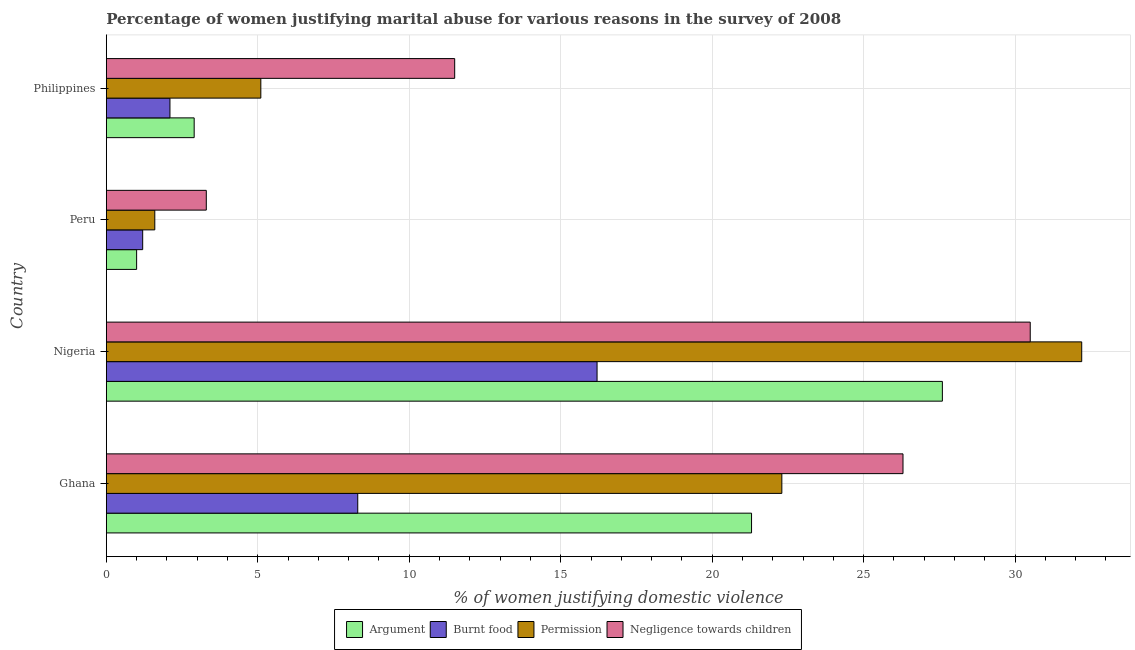How many groups of bars are there?
Give a very brief answer. 4. Are the number of bars on each tick of the Y-axis equal?
Provide a short and direct response. Yes. How many bars are there on the 4th tick from the bottom?
Ensure brevity in your answer.  4. What is the label of the 3rd group of bars from the top?
Give a very brief answer. Nigeria. In how many cases, is the number of bars for a given country not equal to the number of legend labels?
Ensure brevity in your answer.  0. Across all countries, what is the maximum percentage of women justifying abuse for going without permission?
Offer a terse response. 32.2. Across all countries, what is the minimum percentage of women justifying abuse in the case of an argument?
Your answer should be compact. 1. In which country was the percentage of women justifying abuse for going without permission maximum?
Offer a very short reply. Nigeria. In which country was the percentage of women justifying abuse for burning food minimum?
Make the answer very short. Peru. What is the total percentage of women justifying abuse for going without permission in the graph?
Give a very brief answer. 61.2. What is the difference between the percentage of women justifying abuse for showing negligence towards children in Ghana and that in Peru?
Offer a very short reply. 23. What is the difference between the percentage of women justifying abuse in the case of an argument in Nigeria and the percentage of women justifying abuse for burning food in Ghana?
Your response must be concise. 19.3. What is the average percentage of women justifying abuse for burning food per country?
Your response must be concise. 6.95. What is the difference between the percentage of women justifying abuse for going without permission and percentage of women justifying abuse in the case of an argument in Ghana?
Your answer should be very brief. 1. In how many countries, is the percentage of women justifying abuse in the case of an argument greater than 31 %?
Your answer should be very brief. 0. What is the ratio of the percentage of women justifying abuse in the case of an argument in Peru to that in Philippines?
Keep it short and to the point. 0.34. Is the percentage of women justifying abuse in the case of an argument in Nigeria less than that in Philippines?
Your answer should be very brief. No. Is the difference between the percentage of women justifying abuse in the case of an argument in Ghana and Philippines greater than the difference between the percentage of women justifying abuse for burning food in Ghana and Philippines?
Give a very brief answer. Yes. What is the difference between the highest and the second highest percentage of women justifying abuse in the case of an argument?
Ensure brevity in your answer.  6.3. What is the difference between the highest and the lowest percentage of women justifying abuse for showing negligence towards children?
Offer a very short reply. 27.2. Is the sum of the percentage of women justifying abuse for going without permission in Ghana and Nigeria greater than the maximum percentage of women justifying abuse for showing negligence towards children across all countries?
Make the answer very short. Yes. Is it the case that in every country, the sum of the percentage of women justifying abuse for burning food and percentage of women justifying abuse in the case of an argument is greater than the sum of percentage of women justifying abuse for showing negligence towards children and percentage of women justifying abuse for going without permission?
Provide a short and direct response. No. What does the 1st bar from the top in Ghana represents?
Offer a very short reply. Negligence towards children. What does the 1st bar from the bottom in Peru represents?
Offer a very short reply. Argument. Are all the bars in the graph horizontal?
Your answer should be compact. Yes. Does the graph contain any zero values?
Your answer should be compact. No. Does the graph contain grids?
Your answer should be very brief. Yes. How many legend labels are there?
Provide a succinct answer. 4. How are the legend labels stacked?
Keep it short and to the point. Horizontal. What is the title of the graph?
Your answer should be compact. Percentage of women justifying marital abuse for various reasons in the survey of 2008. What is the label or title of the X-axis?
Offer a terse response. % of women justifying domestic violence. What is the % of women justifying domestic violence of Argument in Ghana?
Ensure brevity in your answer.  21.3. What is the % of women justifying domestic violence in Permission in Ghana?
Give a very brief answer. 22.3. What is the % of women justifying domestic violence in Negligence towards children in Ghana?
Your answer should be very brief. 26.3. What is the % of women justifying domestic violence in Argument in Nigeria?
Make the answer very short. 27.6. What is the % of women justifying domestic violence in Permission in Nigeria?
Ensure brevity in your answer.  32.2. What is the % of women justifying domestic violence of Negligence towards children in Nigeria?
Keep it short and to the point. 30.5. What is the % of women justifying domestic violence in Burnt food in Peru?
Provide a short and direct response. 1.2. What is the % of women justifying domestic violence in Permission in Peru?
Provide a short and direct response. 1.6. What is the % of women justifying domestic violence in Burnt food in Philippines?
Your answer should be very brief. 2.1. What is the % of women justifying domestic violence of Permission in Philippines?
Provide a short and direct response. 5.1. Across all countries, what is the maximum % of women justifying domestic violence in Argument?
Provide a succinct answer. 27.6. Across all countries, what is the maximum % of women justifying domestic violence in Burnt food?
Your answer should be very brief. 16.2. Across all countries, what is the maximum % of women justifying domestic violence of Permission?
Make the answer very short. 32.2. Across all countries, what is the maximum % of women justifying domestic violence in Negligence towards children?
Your answer should be compact. 30.5. Across all countries, what is the minimum % of women justifying domestic violence of Argument?
Provide a short and direct response. 1. Across all countries, what is the minimum % of women justifying domestic violence in Burnt food?
Offer a terse response. 1.2. Across all countries, what is the minimum % of women justifying domestic violence in Permission?
Ensure brevity in your answer.  1.6. Across all countries, what is the minimum % of women justifying domestic violence of Negligence towards children?
Provide a succinct answer. 3.3. What is the total % of women justifying domestic violence in Argument in the graph?
Keep it short and to the point. 52.8. What is the total % of women justifying domestic violence of Burnt food in the graph?
Give a very brief answer. 27.8. What is the total % of women justifying domestic violence of Permission in the graph?
Ensure brevity in your answer.  61.2. What is the total % of women justifying domestic violence in Negligence towards children in the graph?
Keep it short and to the point. 71.6. What is the difference between the % of women justifying domestic violence in Argument in Ghana and that in Nigeria?
Provide a short and direct response. -6.3. What is the difference between the % of women justifying domestic violence in Permission in Ghana and that in Nigeria?
Give a very brief answer. -9.9. What is the difference between the % of women justifying domestic violence of Negligence towards children in Ghana and that in Nigeria?
Provide a short and direct response. -4.2. What is the difference between the % of women justifying domestic violence of Argument in Ghana and that in Peru?
Give a very brief answer. 20.3. What is the difference between the % of women justifying domestic violence in Burnt food in Ghana and that in Peru?
Provide a short and direct response. 7.1. What is the difference between the % of women justifying domestic violence in Permission in Ghana and that in Peru?
Keep it short and to the point. 20.7. What is the difference between the % of women justifying domestic violence of Negligence towards children in Ghana and that in Peru?
Make the answer very short. 23. What is the difference between the % of women justifying domestic violence in Burnt food in Ghana and that in Philippines?
Keep it short and to the point. 6.2. What is the difference between the % of women justifying domestic violence in Argument in Nigeria and that in Peru?
Your response must be concise. 26.6. What is the difference between the % of women justifying domestic violence of Permission in Nigeria and that in Peru?
Give a very brief answer. 30.6. What is the difference between the % of women justifying domestic violence in Negligence towards children in Nigeria and that in Peru?
Your response must be concise. 27.2. What is the difference between the % of women justifying domestic violence in Argument in Nigeria and that in Philippines?
Offer a terse response. 24.7. What is the difference between the % of women justifying domestic violence of Burnt food in Nigeria and that in Philippines?
Your answer should be very brief. 14.1. What is the difference between the % of women justifying domestic violence of Permission in Nigeria and that in Philippines?
Give a very brief answer. 27.1. What is the difference between the % of women justifying domestic violence in Negligence towards children in Nigeria and that in Philippines?
Your response must be concise. 19. What is the difference between the % of women justifying domestic violence in Permission in Peru and that in Philippines?
Give a very brief answer. -3.5. What is the difference between the % of women justifying domestic violence of Negligence towards children in Peru and that in Philippines?
Provide a short and direct response. -8.2. What is the difference between the % of women justifying domestic violence of Argument in Ghana and the % of women justifying domestic violence of Permission in Nigeria?
Your answer should be very brief. -10.9. What is the difference between the % of women justifying domestic violence in Burnt food in Ghana and the % of women justifying domestic violence in Permission in Nigeria?
Give a very brief answer. -23.9. What is the difference between the % of women justifying domestic violence of Burnt food in Ghana and the % of women justifying domestic violence of Negligence towards children in Nigeria?
Make the answer very short. -22.2. What is the difference between the % of women justifying domestic violence of Argument in Ghana and the % of women justifying domestic violence of Burnt food in Peru?
Make the answer very short. 20.1. What is the difference between the % of women justifying domestic violence in Argument in Ghana and the % of women justifying domestic violence in Permission in Peru?
Make the answer very short. 19.7. What is the difference between the % of women justifying domestic violence of Argument in Ghana and the % of women justifying domestic violence of Negligence towards children in Peru?
Your answer should be compact. 18. What is the difference between the % of women justifying domestic violence of Burnt food in Ghana and the % of women justifying domestic violence of Permission in Peru?
Ensure brevity in your answer.  6.7. What is the difference between the % of women justifying domestic violence in Permission in Ghana and the % of women justifying domestic violence in Negligence towards children in Peru?
Make the answer very short. 19. What is the difference between the % of women justifying domestic violence in Argument in Ghana and the % of women justifying domestic violence in Burnt food in Philippines?
Provide a succinct answer. 19.2. What is the difference between the % of women justifying domestic violence in Burnt food in Ghana and the % of women justifying domestic violence in Permission in Philippines?
Make the answer very short. 3.2. What is the difference between the % of women justifying domestic violence in Argument in Nigeria and the % of women justifying domestic violence in Burnt food in Peru?
Make the answer very short. 26.4. What is the difference between the % of women justifying domestic violence in Argument in Nigeria and the % of women justifying domestic violence in Negligence towards children in Peru?
Offer a very short reply. 24.3. What is the difference between the % of women justifying domestic violence of Burnt food in Nigeria and the % of women justifying domestic violence of Permission in Peru?
Your answer should be very brief. 14.6. What is the difference between the % of women justifying domestic violence of Permission in Nigeria and the % of women justifying domestic violence of Negligence towards children in Peru?
Give a very brief answer. 28.9. What is the difference between the % of women justifying domestic violence in Argument in Nigeria and the % of women justifying domestic violence in Burnt food in Philippines?
Provide a succinct answer. 25.5. What is the difference between the % of women justifying domestic violence in Argument in Nigeria and the % of women justifying domestic violence in Negligence towards children in Philippines?
Make the answer very short. 16.1. What is the difference between the % of women justifying domestic violence of Burnt food in Nigeria and the % of women justifying domestic violence of Permission in Philippines?
Offer a very short reply. 11.1. What is the difference between the % of women justifying domestic violence of Burnt food in Nigeria and the % of women justifying domestic violence of Negligence towards children in Philippines?
Provide a short and direct response. 4.7. What is the difference between the % of women justifying domestic violence of Permission in Nigeria and the % of women justifying domestic violence of Negligence towards children in Philippines?
Provide a succinct answer. 20.7. What is the difference between the % of women justifying domestic violence in Argument in Peru and the % of women justifying domestic violence in Negligence towards children in Philippines?
Keep it short and to the point. -10.5. What is the difference between the % of women justifying domestic violence of Burnt food in Peru and the % of women justifying domestic violence of Permission in Philippines?
Offer a very short reply. -3.9. What is the difference between the % of women justifying domestic violence of Burnt food in Peru and the % of women justifying domestic violence of Negligence towards children in Philippines?
Provide a succinct answer. -10.3. What is the difference between the % of women justifying domestic violence in Permission in Peru and the % of women justifying domestic violence in Negligence towards children in Philippines?
Make the answer very short. -9.9. What is the average % of women justifying domestic violence in Burnt food per country?
Your response must be concise. 6.95. What is the difference between the % of women justifying domestic violence in Argument and % of women justifying domestic violence in Burnt food in Ghana?
Your answer should be very brief. 13. What is the difference between the % of women justifying domestic violence in Argument and % of women justifying domestic violence in Permission in Ghana?
Your answer should be very brief. -1. What is the difference between the % of women justifying domestic violence of Argument and % of women justifying domestic violence of Negligence towards children in Ghana?
Offer a terse response. -5. What is the difference between the % of women justifying domestic violence in Burnt food and % of women justifying domestic violence in Negligence towards children in Ghana?
Provide a succinct answer. -18. What is the difference between the % of women justifying domestic violence of Argument and % of women justifying domestic violence of Permission in Nigeria?
Make the answer very short. -4.6. What is the difference between the % of women justifying domestic violence of Burnt food and % of women justifying domestic violence of Permission in Nigeria?
Offer a very short reply. -16. What is the difference between the % of women justifying domestic violence of Burnt food and % of women justifying domestic violence of Negligence towards children in Nigeria?
Your response must be concise. -14.3. What is the difference between the % of women justifying domestic violence of Permission and % of women justifying domestic violence of Negligence towards children in Nigeria?
Offer a terse response. 1.7. What is the difference between the % of women justifying domestic violence in Argument and % of women justifying domestic violence in Negligence towards children in Peru?
Your answer should be compact. -2.3. What is the difference between the % of women justifying domestic violence of Argument and % of women justifying domestic violence of Burnt food in Philippines?
Your answer should be very brief. 0.8. What is the difference between the % of women justifying domestic violence of Argument and % of women justifying domestic violence of Permission in Philippines?
Make the answer very short. -2.2. What is the difference between the % of women justifying domestic violence of Argument and % of women justifying domestic violence of Negligence towards children in Philippines?
Make the answer very short. -8.6. What is the difference between the % of women justifying domestic violence in Burnt food and % of women justifying domestic violence in Permission in Philippines?
Provide a short and direct response. -3. What is the difference between the % of women justifying domestic violence of Burnt food and % of women justifying domestic violence of Negligence towards children in Philippines?
Your answer should be compact. -9.4. What is the ratio of the % of women justifying domestic violence of Argument in Ghana to that in Nigeria?
Offer a terse response. 0.77. What is the ratio of the % of women justifying domestic violence in Burnt food in Ghana to that in Nigeria?
Give a very brief answer. 0.51. What is the ratio of the % of women justifying domestic violence of Permission in Ghana to that in Nigeria?
Provide a short and direct response. 0.69. What is the ratio of the % of women justifying domestic violence in Negligence towards children in Ghana to that in Nigeria?
Provide a succinct answer. 0.86. What is the ratio of the % of women justifying domestic violence of Argument in Ghana to that in Peru?
Your answer should be compact. 21.3. What is the ratio of the % of women justifying domestic violence in Burnt food in Ghana to that in Peru?
Your answer should be compact. 6.92. What is the ratio of the % of women justifying domestic violence of Permission in Ghana to that in Peru?
Offer a very short reply. 13.94. What is the ratio of the % of women justifying domestic violence of Negligence towards children in Ghana to that in Peru?
Your response must be concise. 7.97. What is the ratio of the % of women justifying domestic violence of Argument in Ghana to that in Philippines?
Give a very brief answer. 7.34. What is the ratio of the % of women justifying domestic violence of Burnt food in Ghana to that in Philippines?
Provide a succinct answer. 3.95. What is the ratio of the % of women justifying domestic violence of Permission in Ghana to that in Philippines?
Your response must be concise. 4.37. What is the ratio of the % of women justifying domestic violence of Negligence towards children in Ghana to that in Philippines?
Ensure brevity in your answer.  2.29. What is the ratio of the % of women justifying domestic violence in Argument in Nigeria to that in Peru?
Provide a succinct answer. 27.6. What is the ratio of the % of women justifying domestic violence of Permission in Nigeria to that in Peru?
Give a very brief answer. 20.12. What is the ratio of the % of women justifying domestic violence of Negligence towards children in Nigeria to that in Peru?
Ensure brevity in your answer.  9.24. What is the ratio of the % of women justifying domestic violence in Argument in Nigeria to that in Philippines?
Make the answer very short. 9.52. What is the ratio of the % of women justifying domestic violence in Burnt food in Nigeria to that in Philippines?
Provide a succinct answer. 7.71. What is the ratio of the % of women justifying domestic violence in Permission in Nigeria to that in Philippines?
Offer a terse response. 6.31. What is the ratio of the % of women justifying domestic violence of Negligence towards children in Nigeria to that in Philippines?
Offer a terse response. 2.65. What is the ratio of the % of women justifying domestic violence in Argument in Peru to that in Philippines?
Provide a short and direct response. 0.34. What is the ratio of the % of women justifying domestic violence in Permission in Peru to that in Philippines?
Give a very brief answer. 0.31. What is the ratio of the % of women justifying domestic violence of Negligence towards children in Peru to that in Philippines?
Keep it short and to the point. 0.29. What is the difference between the highest and the second highest % of women justifying domestic violence of Argument?
Ensure brevity in your answer.  6.3. What is the difference between the highest and the second highest % of women justifying domestic violence of Permission?
Give a very brief answer. 9.9. What is the difference between the highest and the second highest % of women justifying domestic violence in Negligence towards children?
Provide a succinct answer. 4.2. What is the difference between the highest and the lowest % of women justifying domestic violence of Argument?
Your answer should be very brief. 26.6. What is the difference between the highest and the lowest % of women justifying domestic violence in Permission?
Your answer should be compact. 30.6. What is the difference between the highest and the lowest % of women justifying domestic violence of Negligence towards children?
Provide a succinct answer. 27.2. 